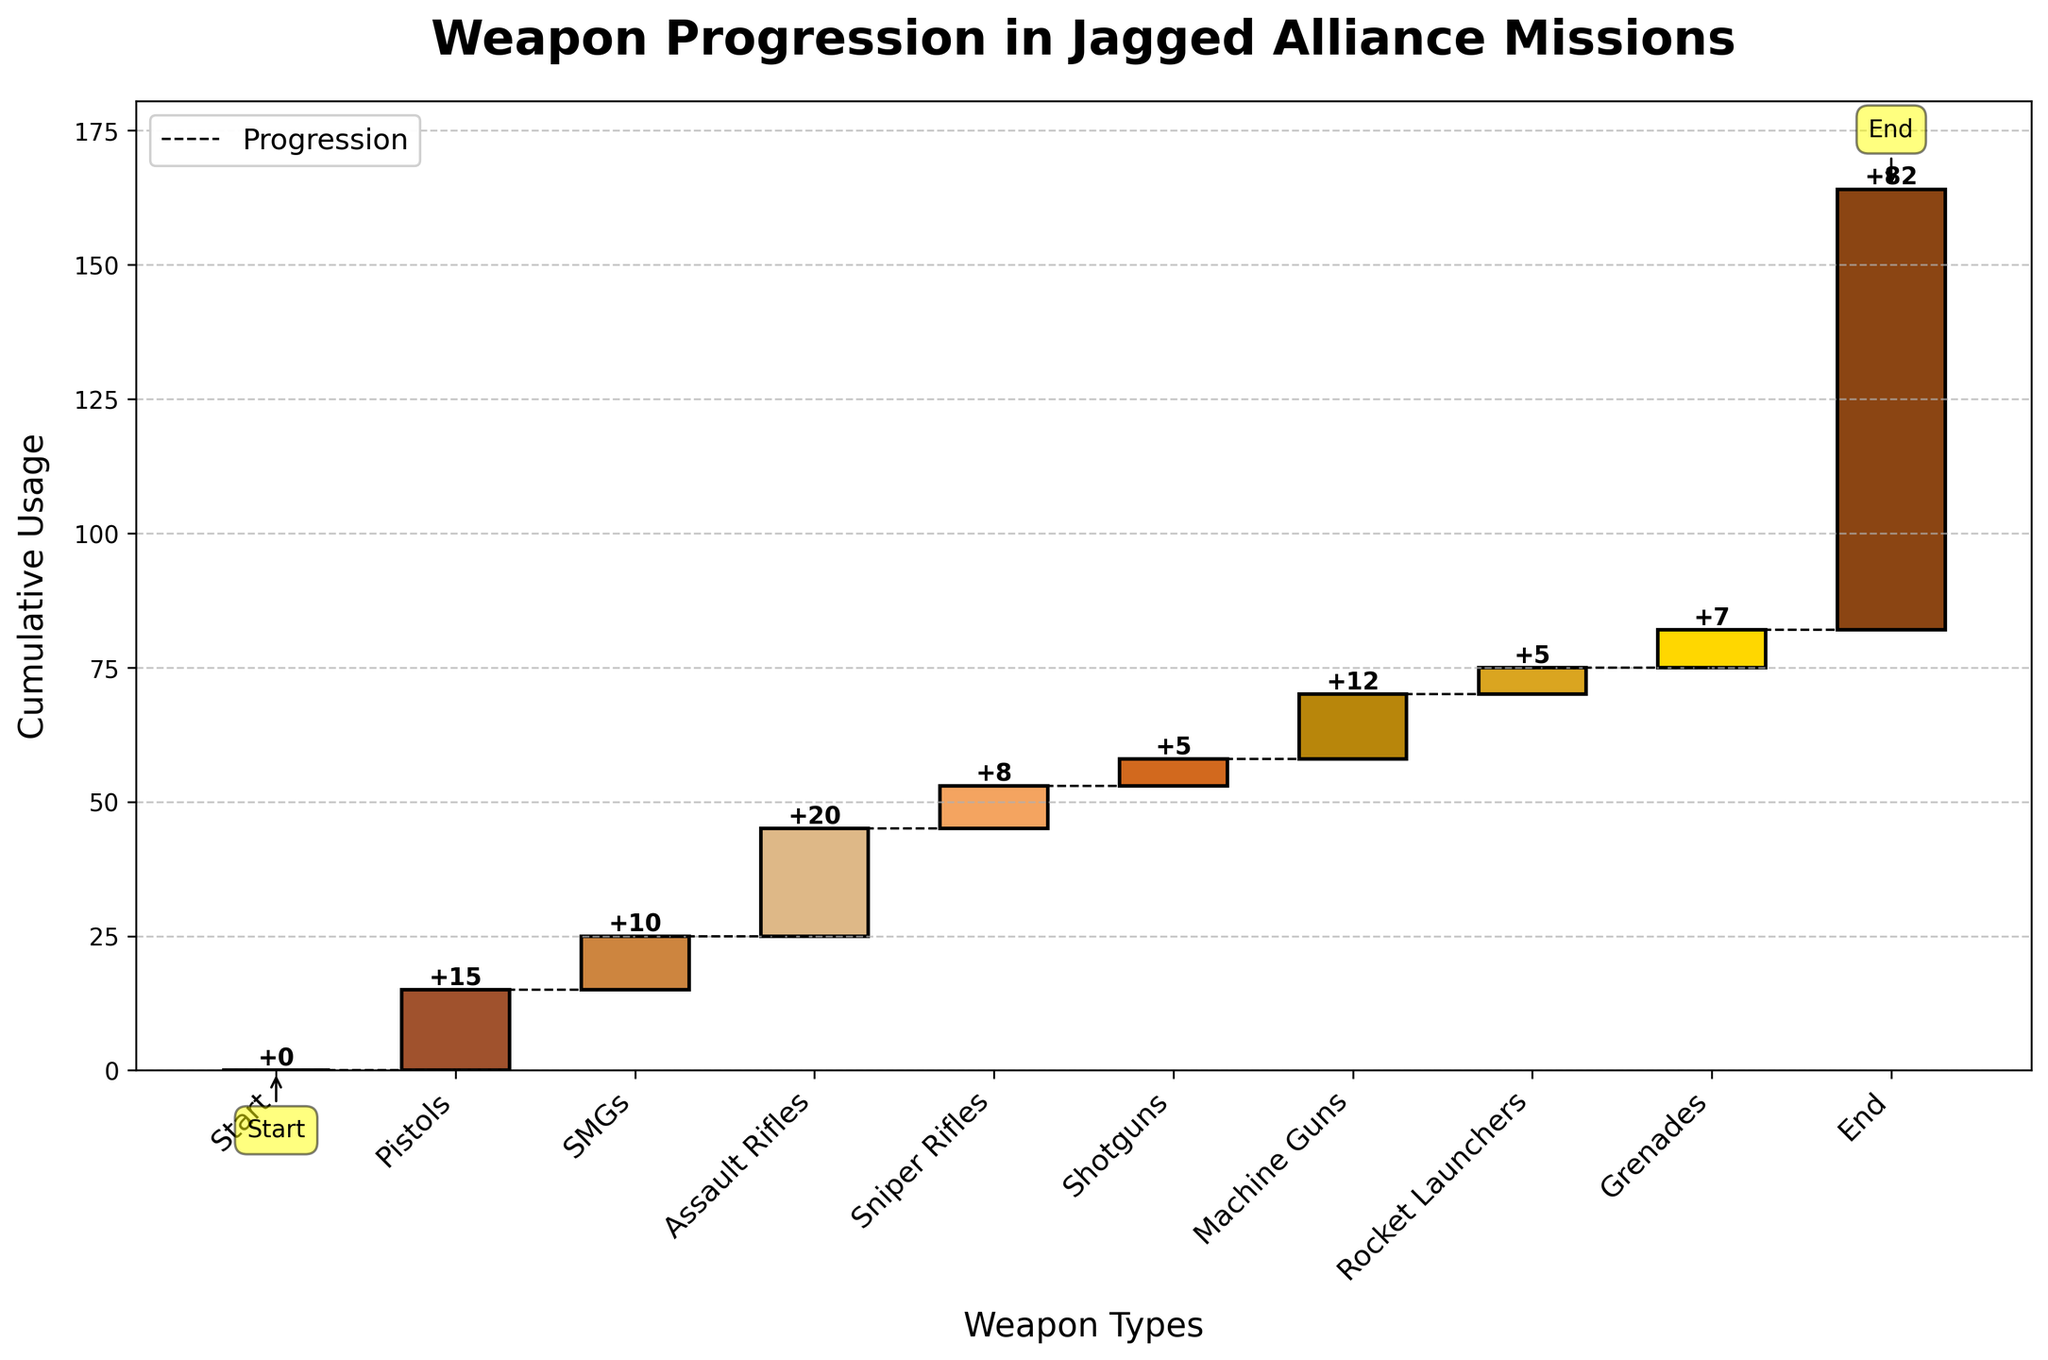What is the title of the chart? The title is located at the top of the chart and provides an overview of what the chart is about. Reading the title, "Weapon Progression in Jagged Alliance Missions," tells us the main subject of the chart.
Answer: Weapon Progression in Jagged Alliance Missions What does the x-axis represent? The x-axis labels are positioned at the bottom of the chart and list the different categories or types of weapons used. The x-axis represents "Weapon Types."
Answer: Weapon Types What is the cumulative usage value for Assault Rifles? Locate the bar corresponding to "Assault Rifles" on the x-axis and look up to find the top of the bar. The cumulative usage value is written on the chart.
Answer: 45 How many weapon types are included in the chart? Each label along the x-axis represents a different weapon type. Counting them will give the total number. Ensure to include the Start and End points.
Answer: 9 What is the total increase in usage from Pistols to Grenades? Add up the values of all the weapon types from Pistols to Grenades (15 + 10 + 20 + 8 + 5 + 12 + 5 + 7).
Answer: 82 Which weapon type follows Assault Rifles? Find the position of "Assault Rifles" along the x-axis and identify the category immediately after it. The next category is "Sniper Rifles."
Answer: Sniper Rifles How many weapon types have a usage increase greater than 10? Check the values for each weapon type. Compare each value to 10 and count how many exceed this number (Pistols, Assault Rifles, Machine Guns).
Answer: 3 What is the difference in the cumulative usage between SMGs and Grenades? Find the cumulative usage for both SMGs and Grenades, then calculate the difference (25 - 82). The values can be read from the chart.
Answer: 57 Which weapon type has the smallest usage increase? Compare the values for each weapon type and identify the smallest one. "Shotguns" has the smallest increase.
Answer: Shotguns Is the cumulative usage at the end point higher or lower than the sum of all individual weapon increases? Calculate the sum of all individual weapon increases and compare it to the cumulative usage value at the end. Both values should match if the chart is accurate.
Answer: The same 